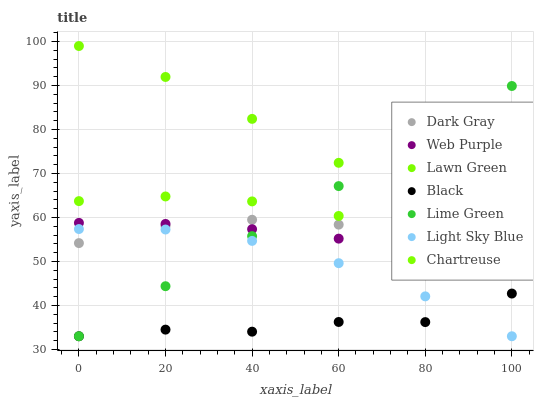Does Black have the minimum area under the curve?
Answer yes or no. Yes. Does Lawn Green have the maximum area under the curve?
Answer yes or no. Yes. Does Chartreuse have the minimum area under the curve?
Answer yes or no. No. Does Chartreuse have the maximum area under the curve?
Answer yes or no. No. Is Lime Green the smoothest?
Answer yes or no. Yes. Is Black the roughest?
Answer yes or no. Yes. Is Chartreuse the smoothest?
Answer yes or no. No. Is Chartreuse the roughest?
Answer yes or no. No. Does Light Sky Blue have the lowest value?
Answer yes or no. Yes. Does Chartreuse have the lowest value?
Answer yes or no. No. Does Lawn Green have the highest value?
Answer yes or no. Yes. Does Chartreuse have the highest value?
Answer yes or no. No. Is Black less than Web Purple?
Answer yes or no. Yes. Is Lawn Green greater than Chartreuse?
Answer yes or no. Yes. Does Light Sky Blue intersect Dark Gray?
Answer yes or no. Yes. Is Light Sky Blue less than Dark Gray?
Answer yes or no. No. Is Light Sky Blue greater than Dark Gray?
Answer yes or no. No. Does Black intersect Web Purple?
Answer yes or no. No. 